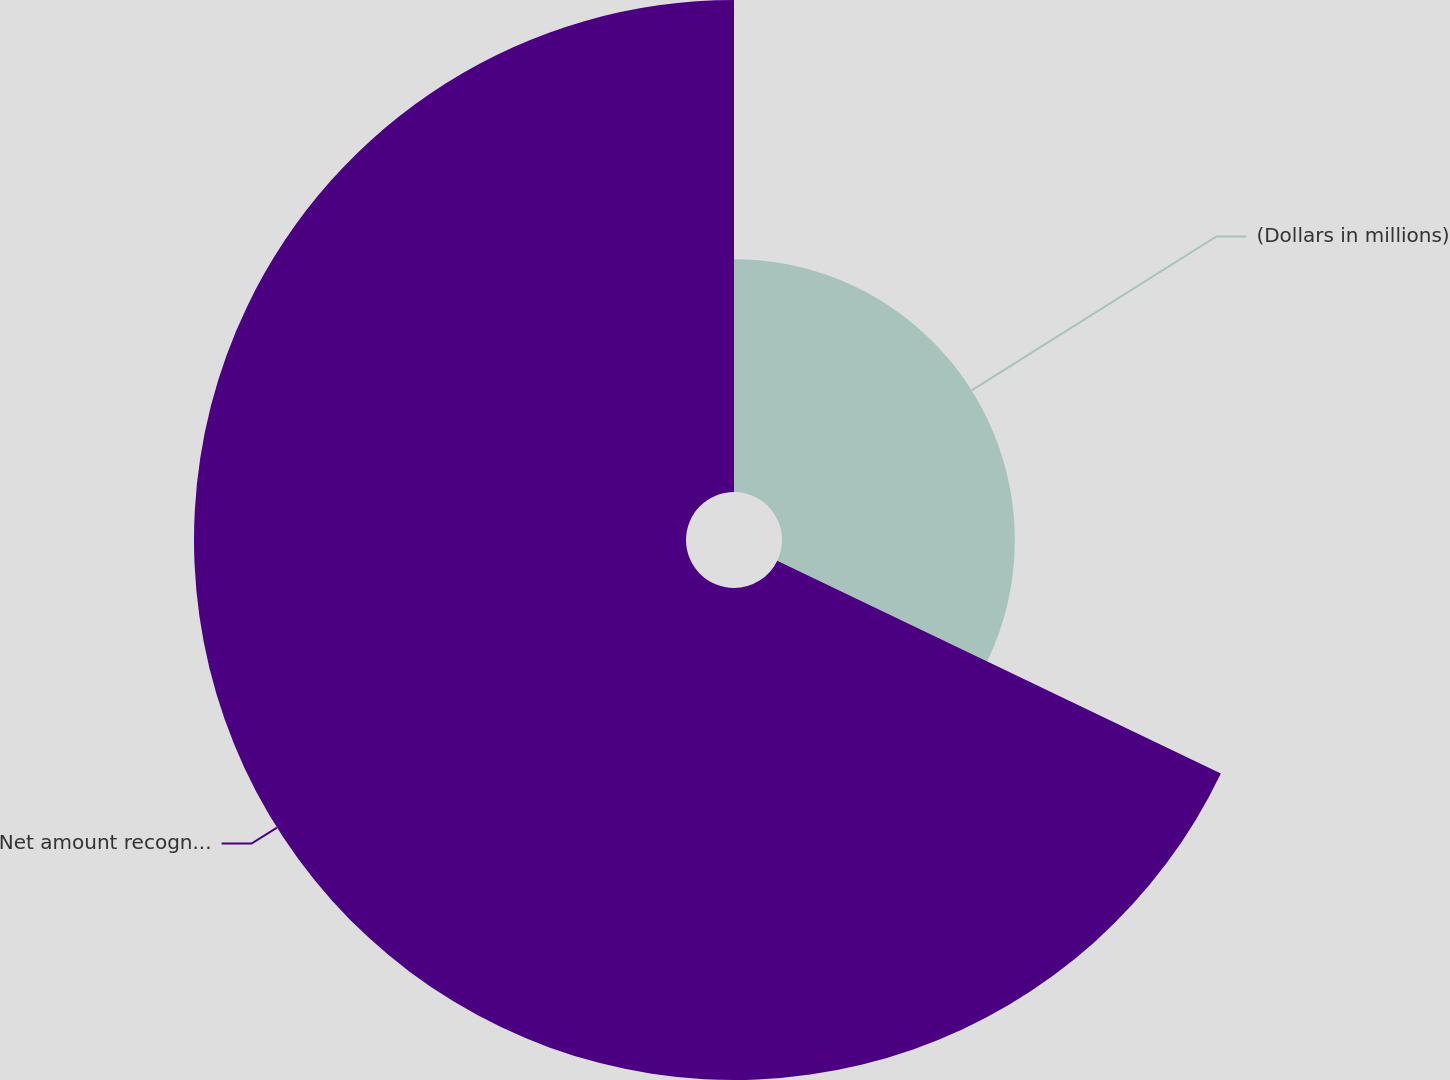Convert chart. <chart><loc_0><loc_0><loc_500><loc_500><pie_chart><fcel>(Dollars in millions)<fcel>Net amount recognized at<nl><fcel>32.12%<fcel>67.88%<nl></chart> 